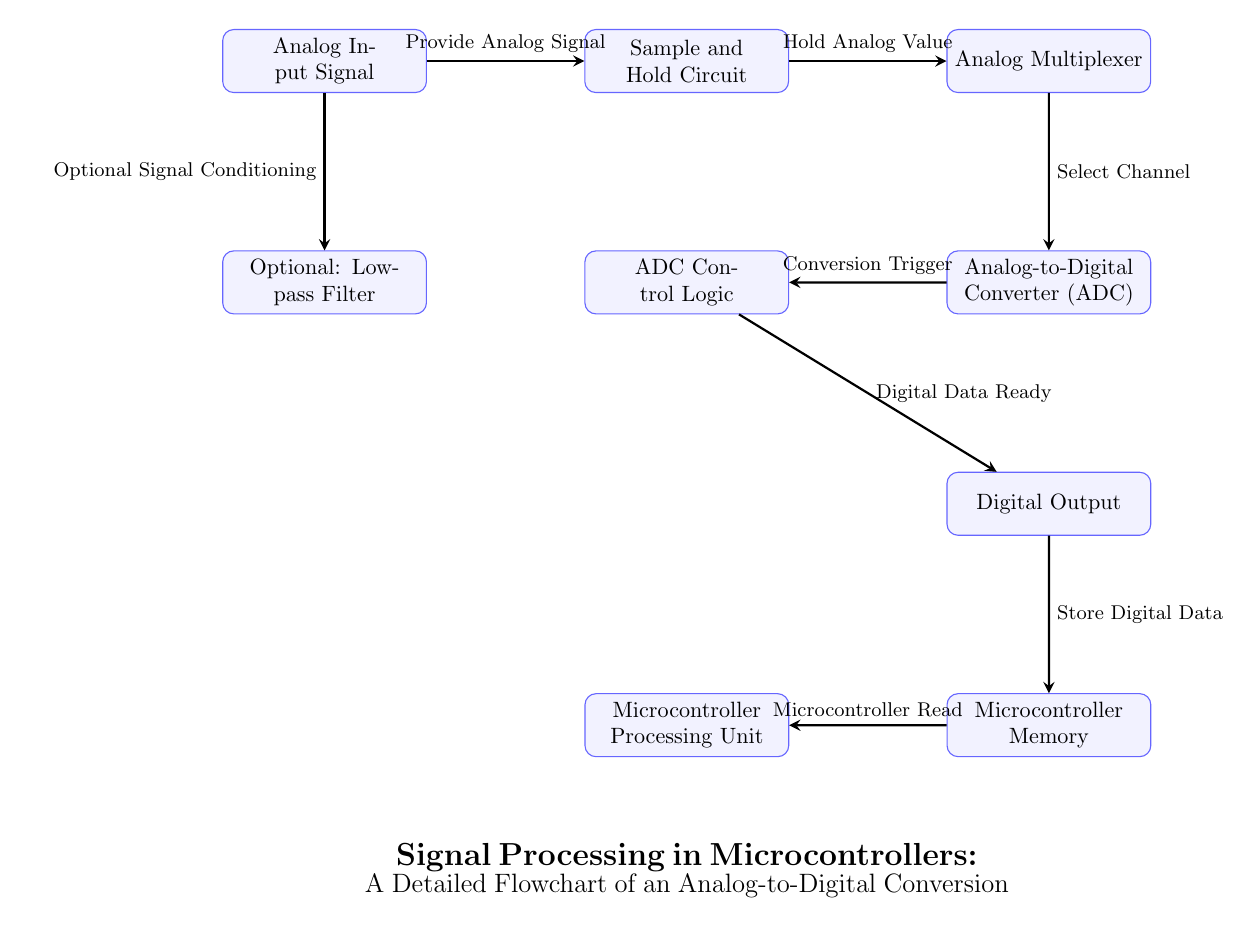What is the first step in the flowchart? The first step in the flowchart is the "Analog Input Signal," which is where the process begins.
Answer: Analog Input Signal How many processes are involved in the conversion? By counting the rectangles labeled as processes in the diagram, we find there are seven distinct processes listed.
Answer: 7 What follows the Sample and Hold Circuit? The process that follows the Sample and Hold Circuit is the "Analog Multiplexer." This can be seen as the arrow points directly from the Sample and Hold Circuit to the Analog Multiplexer.
Answer: Analog Multiplexer What is the role of the ADC Control Logic in this flowchart? The ADC Control Logic is responsible for triggering the conversion once the analog value is ready, as indicated by the arrow that states "Conversion Trigger."
Answer: Conversion Trigger What optional component is shown in the flowchart? The flowchart includes an optional component known as the "Low-pass Filter," which is connected to the Analog Input Signal, indicating that it may condition the signal before processing.
Answer: Low-pass Filter What does the arrow leading from the Analog-to-Digital Converter point toward? The arrow leading from the Analog-to-Digital Converter points toward the ADC Control Logic, indicating that the control logic receives information from the ADC for further processing.
Answer: ADC Control Logic How does the Digital Output relate to Microcontroller Memory? The Digital Output feeds into Microcontroller Memory, which is indicated by the "Store Digital Data" label on the arrow connecting the two processes.
Answer: Store Digital Data What signal is provided to the Sample and Hold Circuit? The signal provided to the Sample and Hold Circuit is the "Analog Signal," indicating that this process depends on the input analog value.
Answer: Provide Analog Signal What action does the Microcontroller Processing Unit perform? The Microcontroller Processing Unit performs the action of reading the stored digital data, as evidenced by the connecting arrow stating "Microcontroller Read."
Answer: Microcontroller Read 